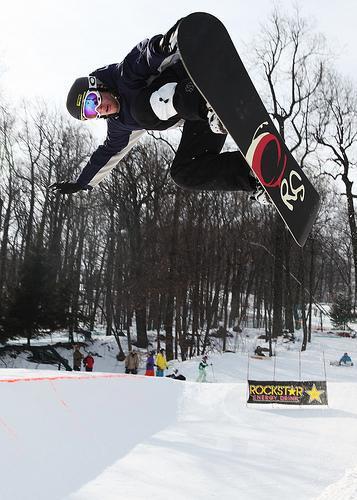How many people are snowboarding?
Give a very brief answer. 1. 